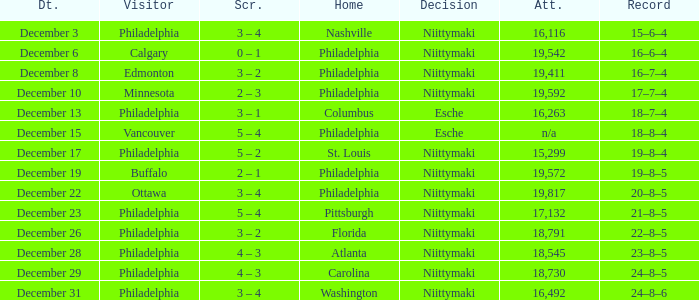What was the score when the attendance was 18,545? 4 – 3. 